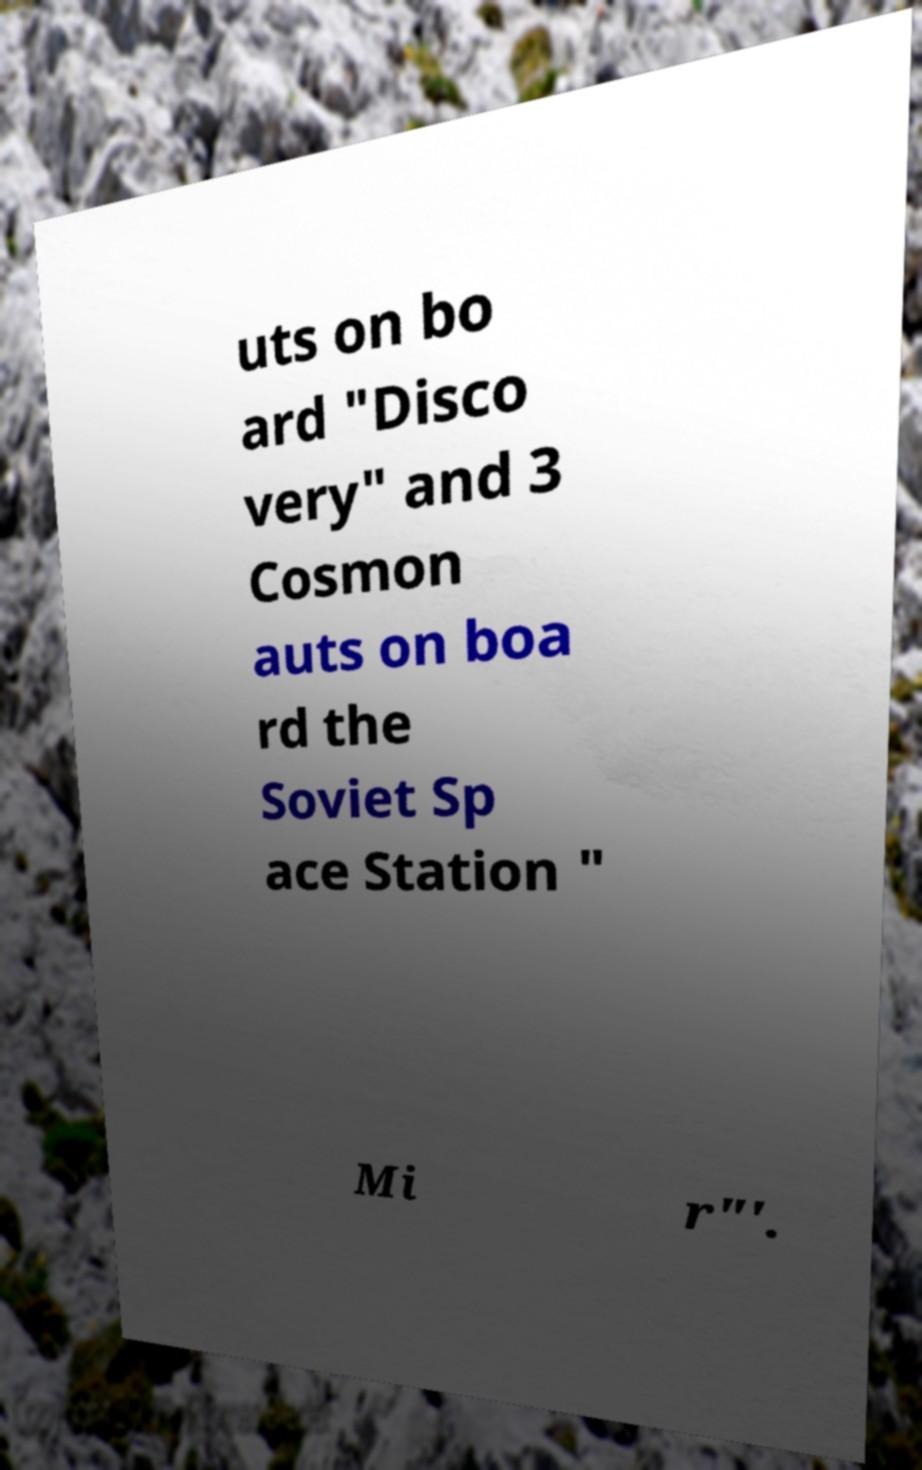Could you extract and type out the text from this image? uts on bo ard "Disco very" and 3 Cosmon auts on boa rd the Soviet Sp ace Station " Mi r"'. 